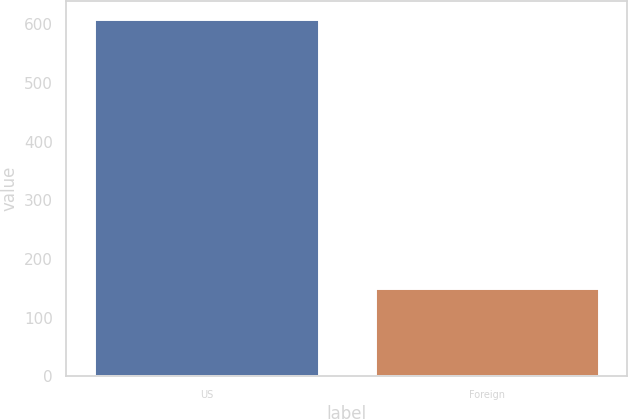Convert chart to OTSL. <chart><loc_0><loc_0><loc_500><loc_500><bar_chart><fcel>US<fcel>Foreign<nl><fcel>609<fcel>150<nl></chart> 